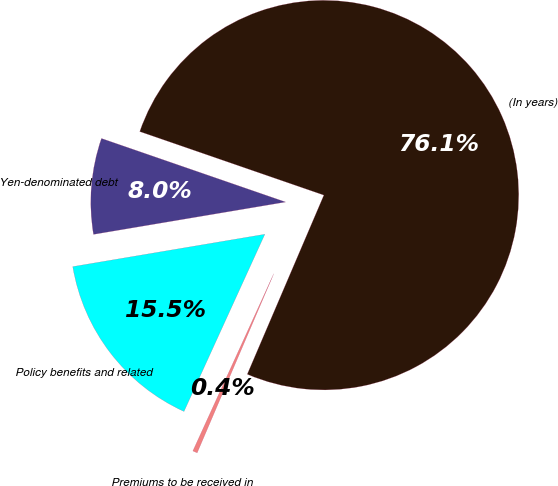Convert chart to OTSL. <chart><loc_0><loc_0><loc_500><loc_500><pie_chart><fcel>(In years)<fcel>Yen-denominated debt<fcel>Policy benefits and related<fcel>Premiums to be received in<nl><fcel>76.14%<fcel>7.95%<fcel>15.53%<fcel>0.38%<nl></chart> 